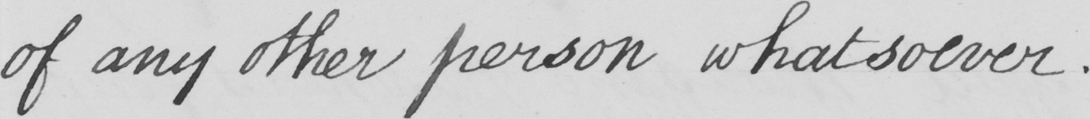What text is written in this handwritten line? of any other person whatsoever . 